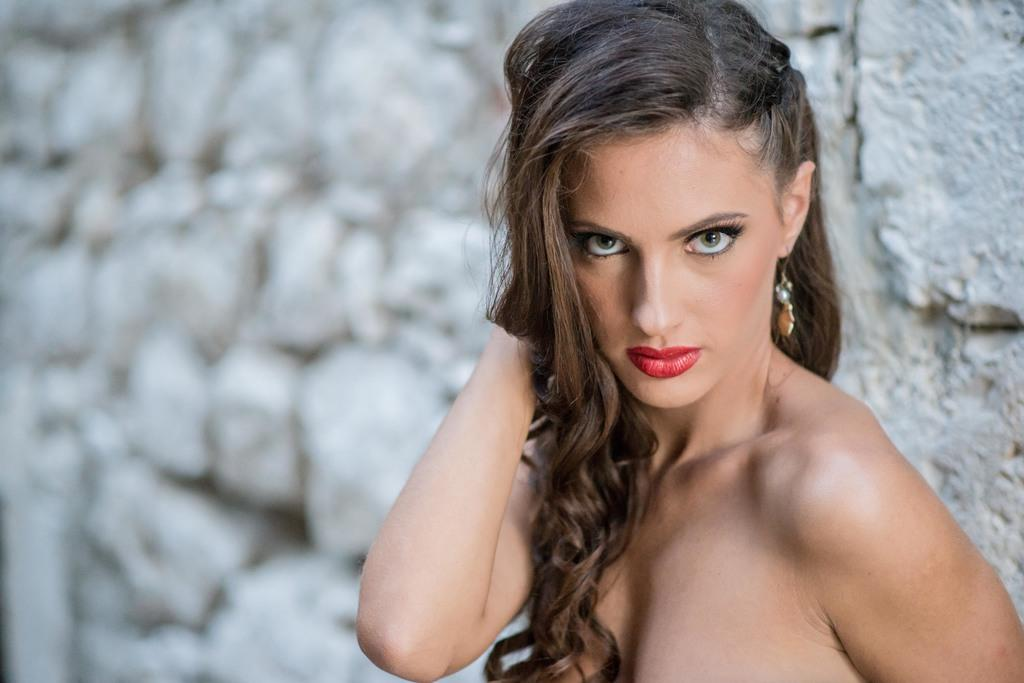Who is the main subject in the picture? There is a woman in the picture. What is the woman doing in the image? The woman is standing and giving a pose. What can be seen in the background of the picture? There is a wall with rocks in the background of the picture. How many kittens are sitting on the rocks in the background of the image? There are no kittens present in the image; the background features a wall with rocks. What type of material is the floor made of in the image? The provided facts do not mention the floor material in the image. 